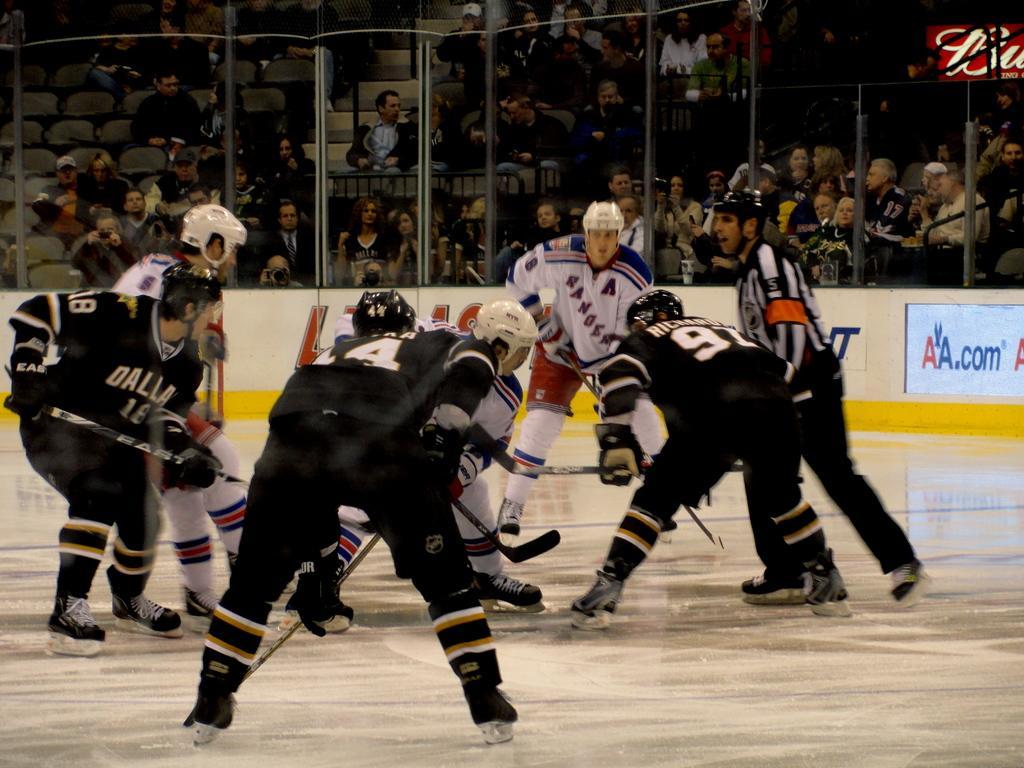How would you summarize this image in a sentence or two? Here I can see few people wearing T-shirts, helmets to the heads, holding bats in the hands and playing a game on the floor. In the background there is a board on which I can see some text. At the back of it I can see many people are sitting on the chairs and looking at the people who are playing. 